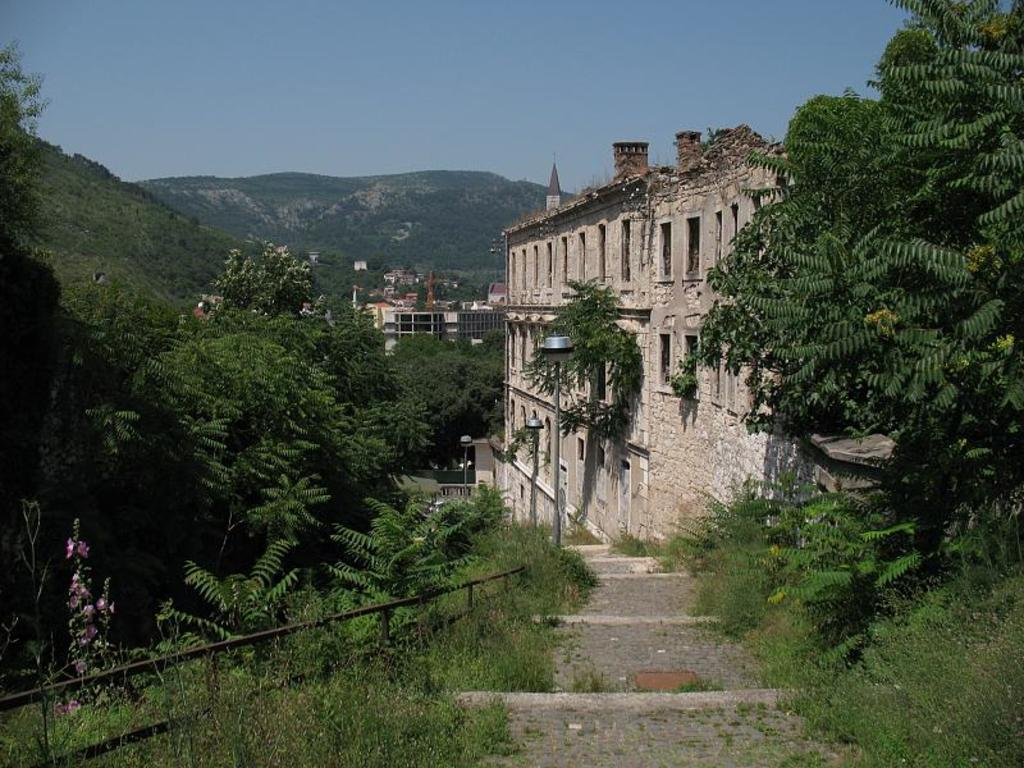What type of natural elements can be seen in the image? There are trees in the image. What type of man-made structures are present in the image? There are buildings in the image. What objects are supporting the lights in the image? There are poles in the image. What are the lights used for in the image? The lights are used for illumination. What type of landscape feature can be seen in the background of the image? There are hills in the background of the image. What time of day is it in the image, and how can we tell? The time of day cannot be determined from the image, as there are no clues such as shadows or the position of the sun. How many buttons are present in the image? There are no buttons visible in the image. 